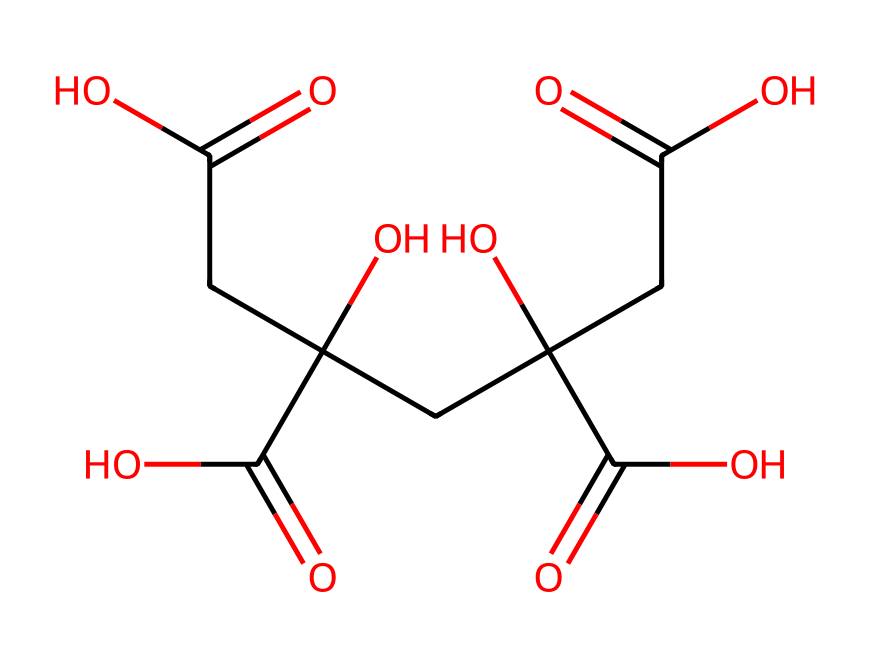how many carbon atoms are in citric acid? To determine the number of carbon atoms, we examine the structure represented by the SMILES. The “C” in the SMILES notation indicates carbon atoms. By counting the "C" representations in the provided SMILES string, we find there are six carbon atoms.
Answer: six what is the main functional group present in citric acid? The prominent functional group in citric acid is the carboxylic acid group, which can be identified by the presence of “C(=O)O” in the SMILES notation. This indicates the presence of the -COOH functional group.
Answer: carboxylic acid how many hydroxyl (–OH) groups are present in citric acid? The hydroxyl groups are represented in the SMILES by “O” directly attached to the carbon atoms. By examining the structure, we can see that there are three hydroxyl groups present.
Answer: three what is the total number of hydrogen atoms in citric acid? To find the total number of hydrogen atoms, we use the formula for hydrocarbons and consider the non-hydrogen atoms from the SMILES. Counting the attached hydrogen atoms through deduction or implicit representation, we find there are eight hydrogen atoms in total.
Answer: eight is citric acid a saturated or unsaturated compound? To determine if citric acid is saturated or unsaturated, we analyze its structure for double bonds. The presence of C(=O) indicates the presence of double bonds, suggesting it is unsaturated.
Answer: unsaturated what type of compound is citric acid categorized as? Citric acid is categorized as an aliphatic compound due to its open-chain structure, which consists predominantly of carbon and hydrogen atoms without any cyclic features.
Answer: aliphatic 